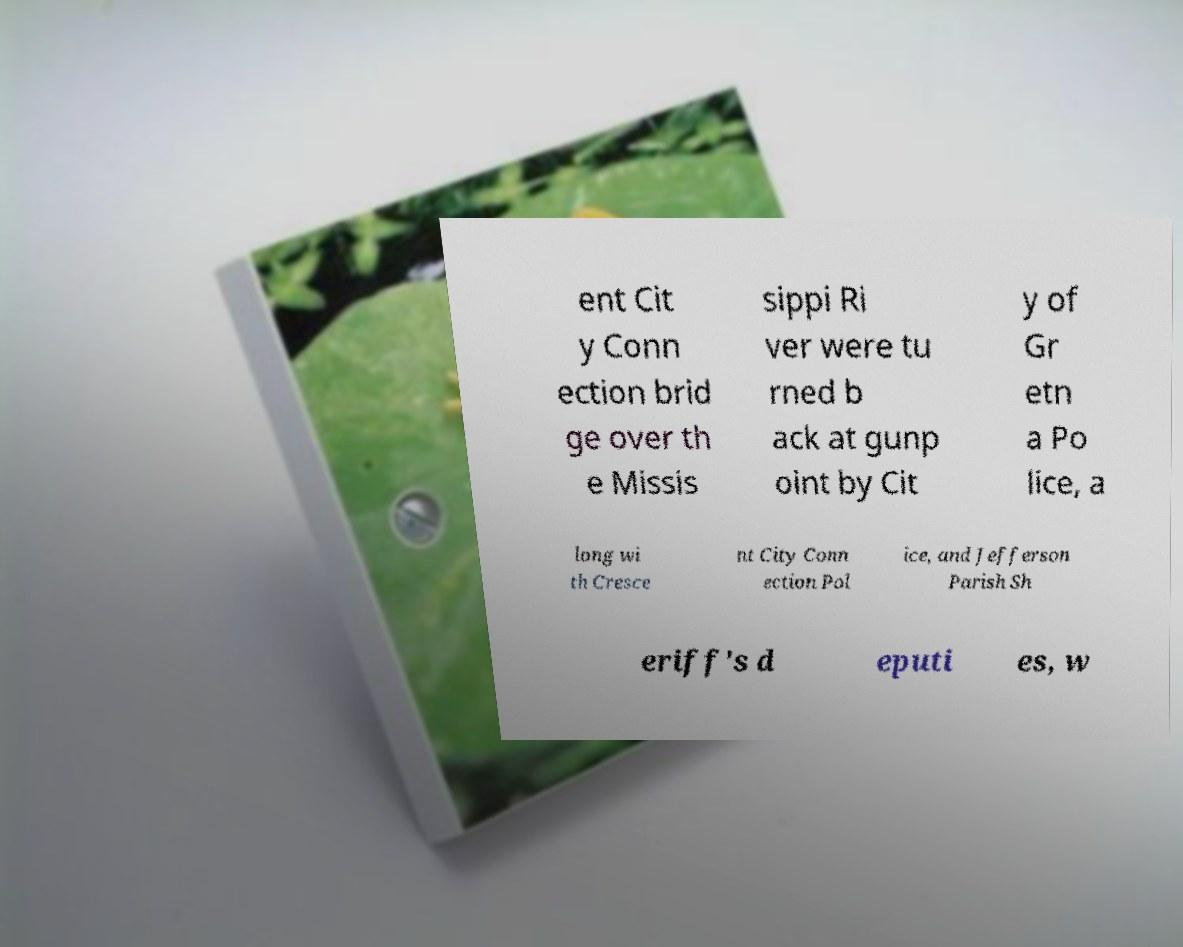Could you assist in decoding the text presented in this image and type it out clearly? ent Cit y Conn ection brid ge over th e Missis sippi Ri ver were tu rned b ack at gunp oint by Cit y of Gr etn a Po lice, a long wi th Cresce nt City Conn ection Pol ice, and Jefferson Parish Sh eriff's d eputi es, w 